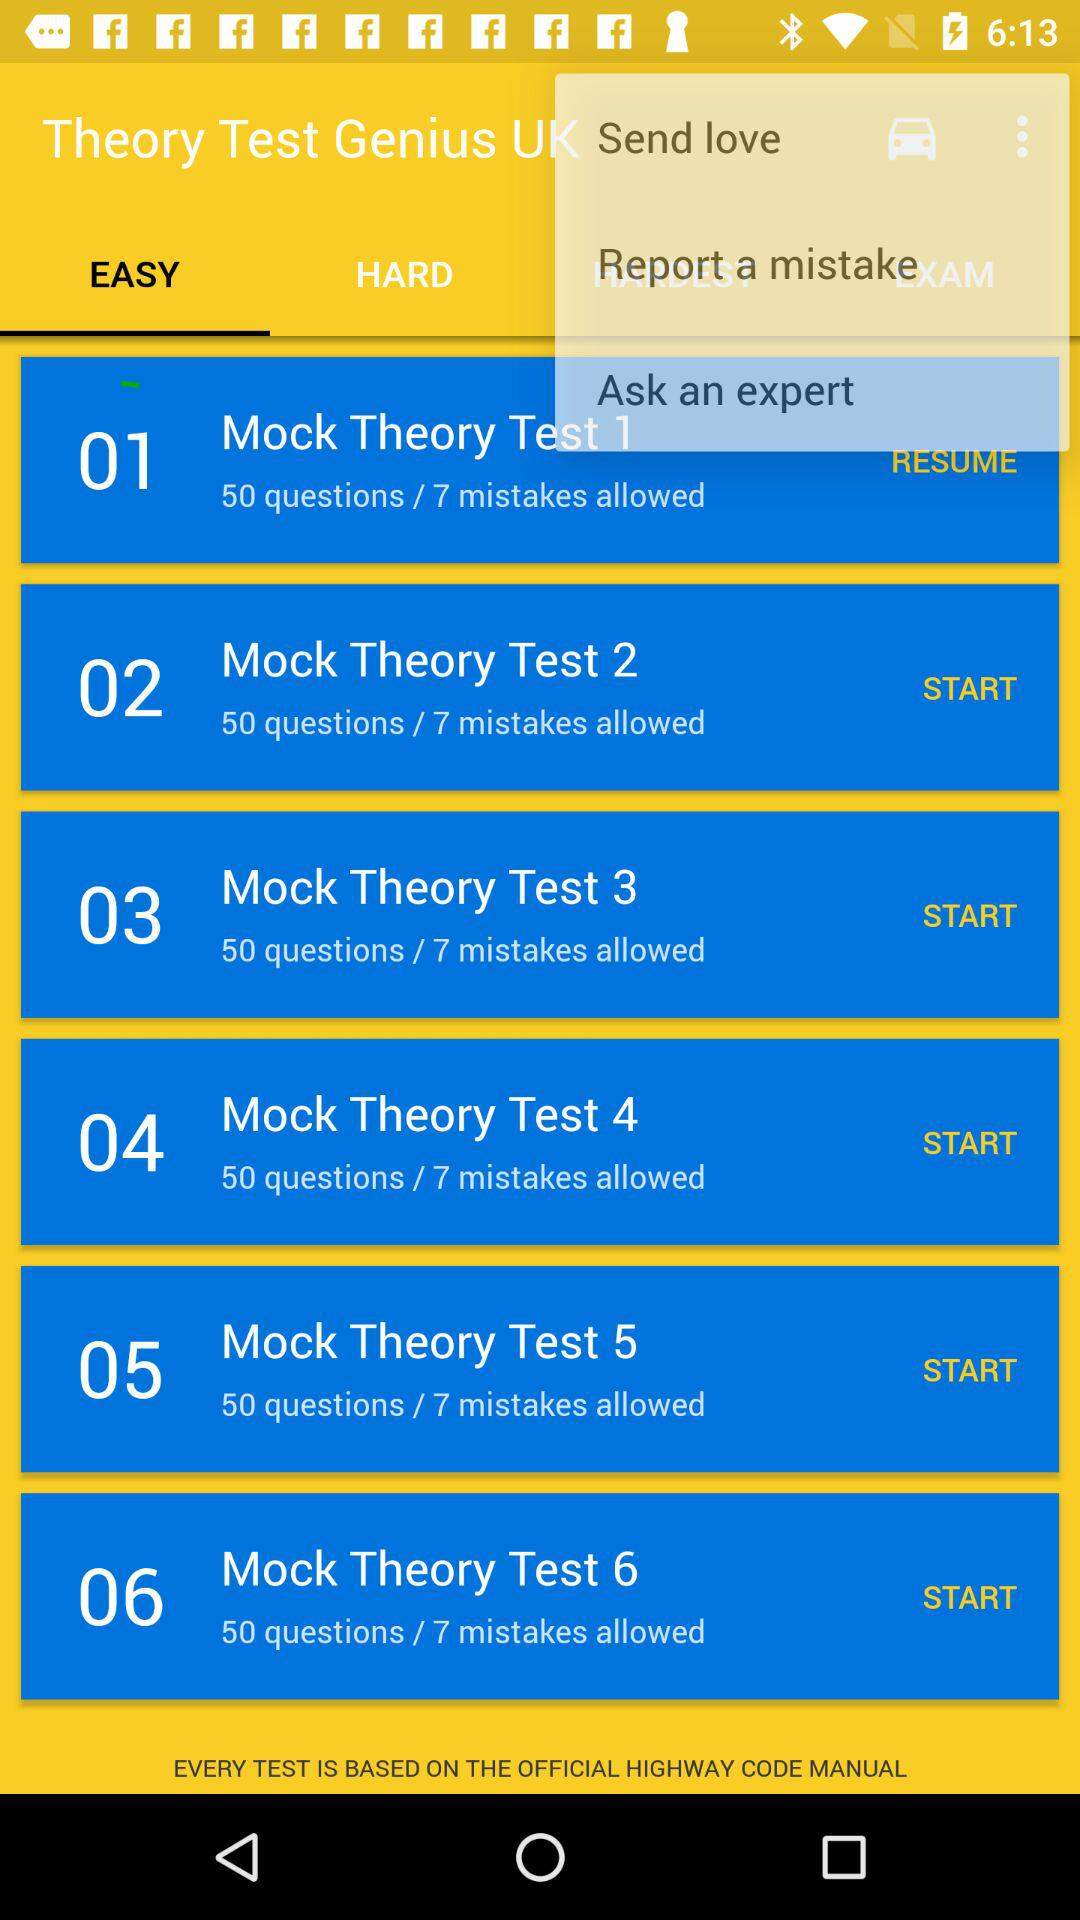Which tab is selected? The selected tab is "EASY". 